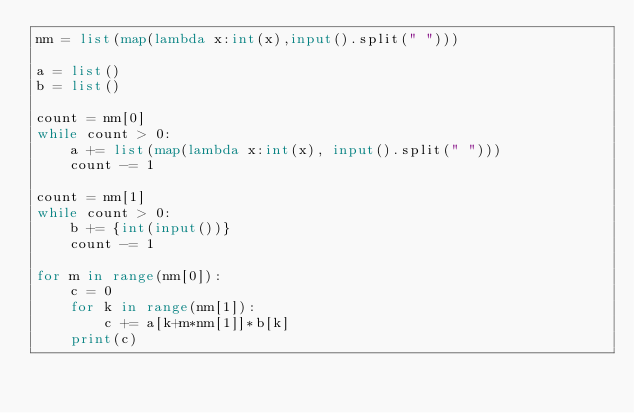Convert code to text. <code><loc_0><loc_0><loc_500><loc_500><_Python_>nm = list(map(lambda x:int(x),input().split(" ")))

a = list()
b = list()

count = nm[0]
while count > 0:
    a += list(map(lambda x:int(x), input().split(" ")))
    count -= 1

count = nm[1]
while count > 0:
    b += {int(input())}
    count -= 1

for m in range(nm[0]):
    c = 0
    for k in range(nm[1]):
        c += a[k+m*nm[1]]*b[k]
    print(c)</code> 